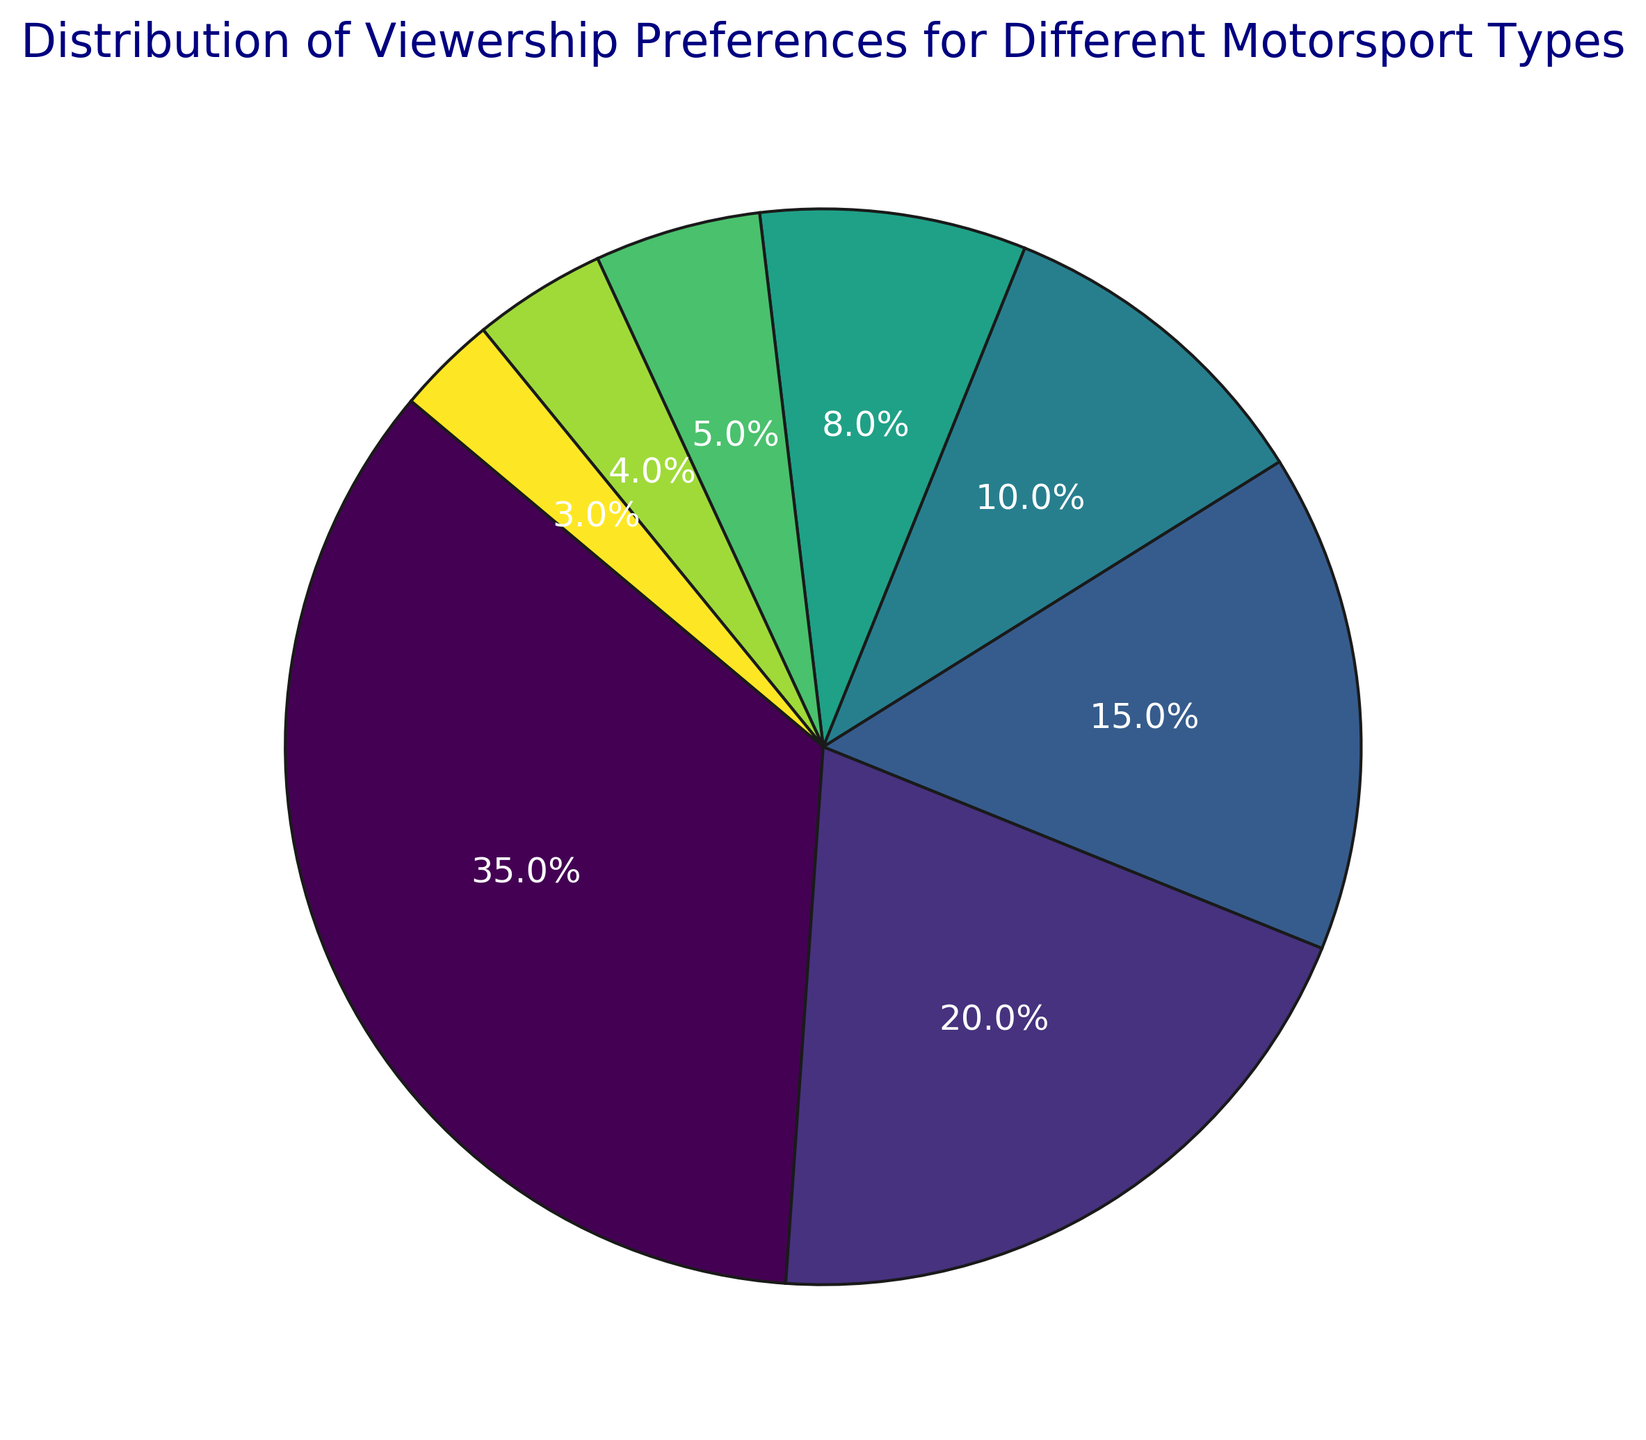What is the most preferred motorsport type according to the figure? The figure shows the distribution of viewership preferences, and the largest segment belongs to F1. The label indicates it has a 35% share of total viewership preferences.
Answer: F1 Which motorsport type has the least viewership preference? The smallest segment in the pie chart is labeled "Other," which has a 3% share of the total viewership preferences.
Answer: Other What are the combined viewership preferences for Rally, IndyCar, and WRC? The viewership percentages for Rally, IndyCar, and WRC are 10%, 8%, and 5%, respectively. Summing them gives 10% + 8% + 5% = 23%.
Answer: 23% Which motorsport type has a higher viewership percentage, MotoGP or Nascar? The pie chart shows that MotoGP has a 20% viewership percentage, while Nascar has a 15% viewership percentage. Therefore, MotoGP has a higher viewership percentage than Nascar.
Answer: MotoGP Are F1 and MotoGP's combined viewership preferences more than half of the total viewership preferences? F1 accounts for 35% and MotoGP accounts for 20%. The combined viewership is 35% + 20% = 55%, which is more than half (50%) of the total viewership preferences.
Answer: Yes What is the difference in viewership percentage between WRC and Formula E? The pie chart shows WRC has a 5% viewership percentage, and Formula E has a 4% viewership percentage. The difference is 5% - 4% = 1%.
Answer: 1% Which motorsport type's segment is closest in size to the Nascar segment? The pie chart shows Nascar with a 15% viewership percentage. The closest segment in size is Rally with a 10% viewership percentage.
Answer: Rally What fraction of the total viewership belongs to categories with less than 10% share? Categories with less than 10% share are Rally (10%), IndyCar (8%), WRC (5%), Formula E (4%), and Other (3%). Summing them gives 10% + 8% + 5% + 4% + 3% = 30%.
Answer: 30% If only F1 and MotoGP were broadcasted, what percentage of the total viewership would be other motorsports? Combining F1 (35%) and MotoGP (20%) gives 35% + 20% = 55%. The remaining viewership percentage would be 100% - 55% = 45%.
Answer: 45% Which segment is represented with the darkest color? The figure uses the viridis colormap, where the darkest color usually corresponds to the highest value. Hence, the F1 segment (35%) should be represented with the darkest color.
Answer: F1 